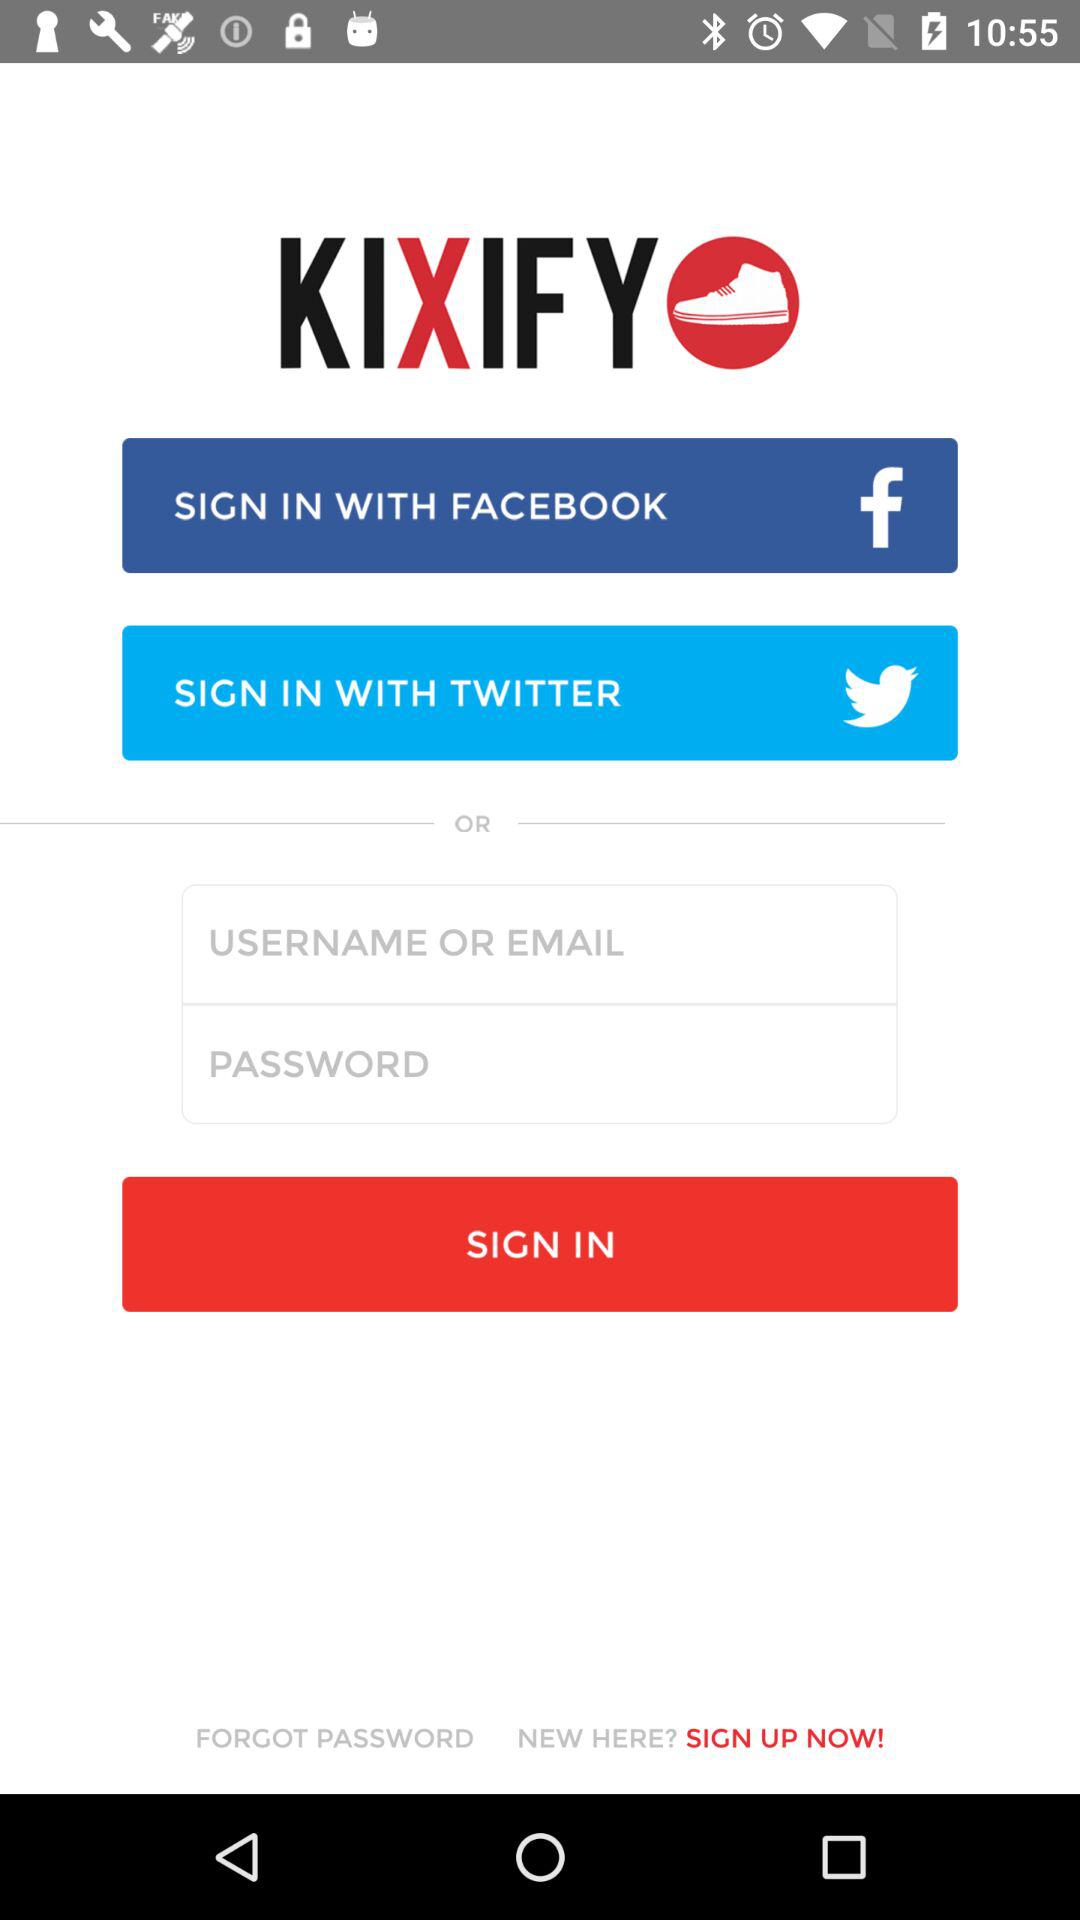How many input fields are there for logging in?
Answer the question using a single word or phrase. 2 